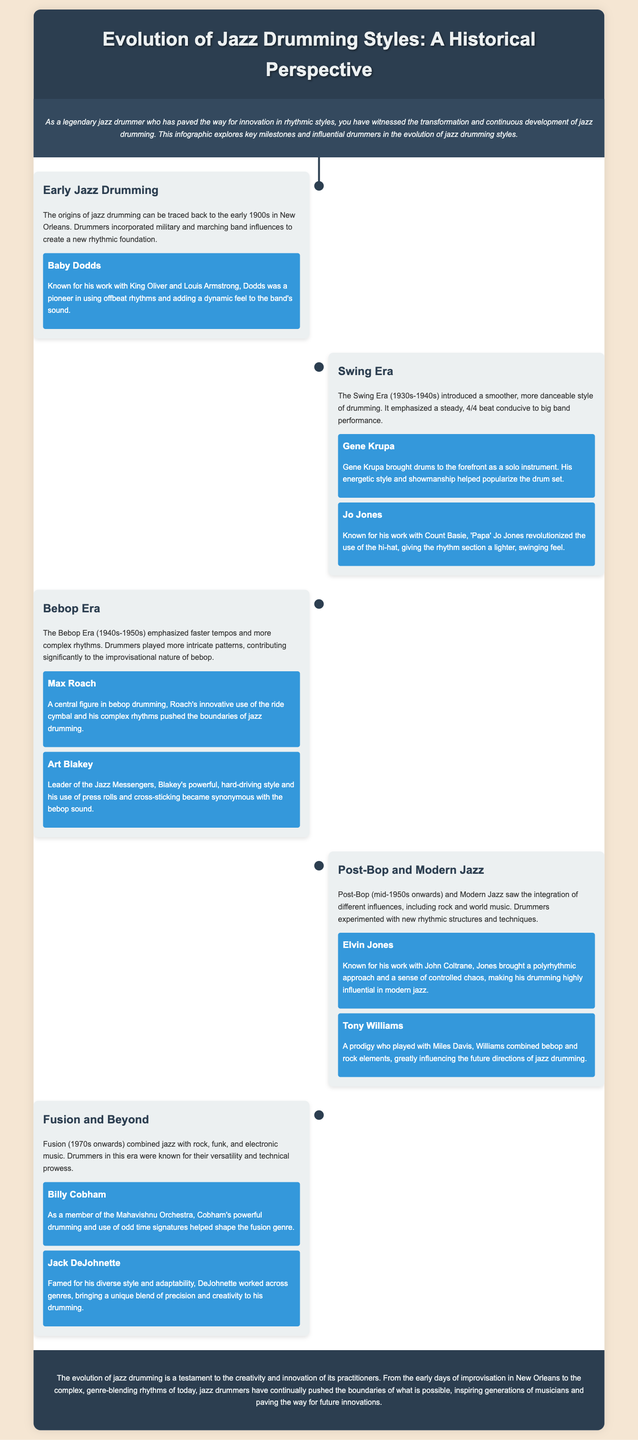what decade did the Swing Era occur? The Swing Era is noted to have taken place during the 1930s-1940s.
Answer: 1930s-1940s who is known for his work with King Oliver and Louis Armstrong? Baby Dodds is recognized for his collaborations with King Oliver and Louis Armstrong.
Answer: Baby Dodds which drummer revolutionized the use of the hi-hat? 'Papa' Jo Jones is acknowledged for his groundbreaking use of the hi-hat in drumming.
Answer: Jo Jones what genre did Billy Cobham help shape? The document states that Billy Cobham was influential in shaping the fusion genre.
Answer: fusion which drummer is noted for playing with John Coltrane? Elvin Jones is specifically mentioned for his work with John Coltrane.
Answer: Elvin Jones what rhythmic approach is associated with Elvin Jones? Elvin Jones is identified for his polyrhythmic approach and controlled chaos.
Answer: polyrhythmic how did the Bebop Era influence drumming? The Bebop Era introduced faster tempos and more complex rhythms into drumming.
Answer: complex rhythms name one key figure from the Early Jazz Drumming era. The document lists Baby Dodds as a key figure from the Early Jazz Drumming era.
Answer: Baby Dodds 